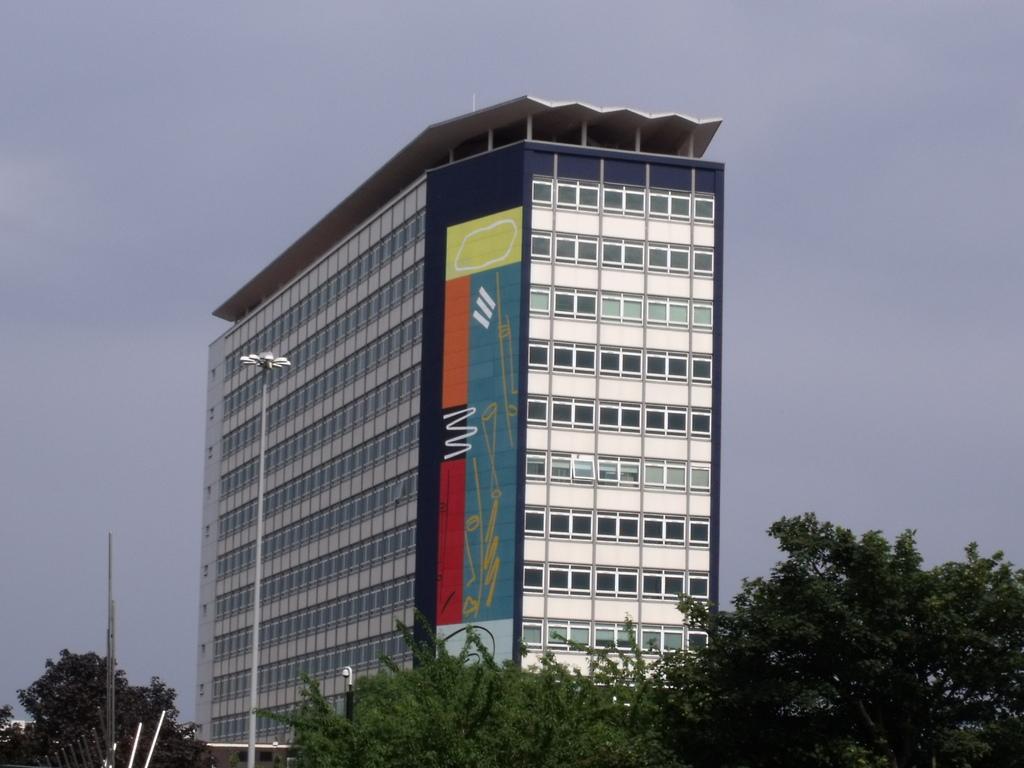Could you give a brief overview of what you see in this image? This picture is clicked outside. In the foreground we can see the trees and metal rods and a pole. In the background there is a building and the sky. 